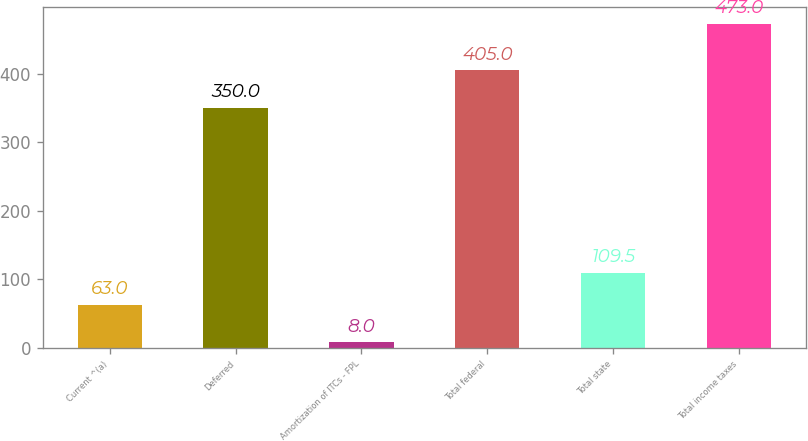Convert chart to OTSL. <chart><loc_0><loc_0><loc_500><loc_500><bar_chart><fcel>Current ^(a)<fcel>Deferred<fcel>Amortization of ITCs - FPL<fcel>Total federal<fcel>Total state<fcel>Total income taxes<nl><fcel>63<fcel>350<fcel>8<fcel>405<fcel>109.5<fcel>473<nl></chart> 